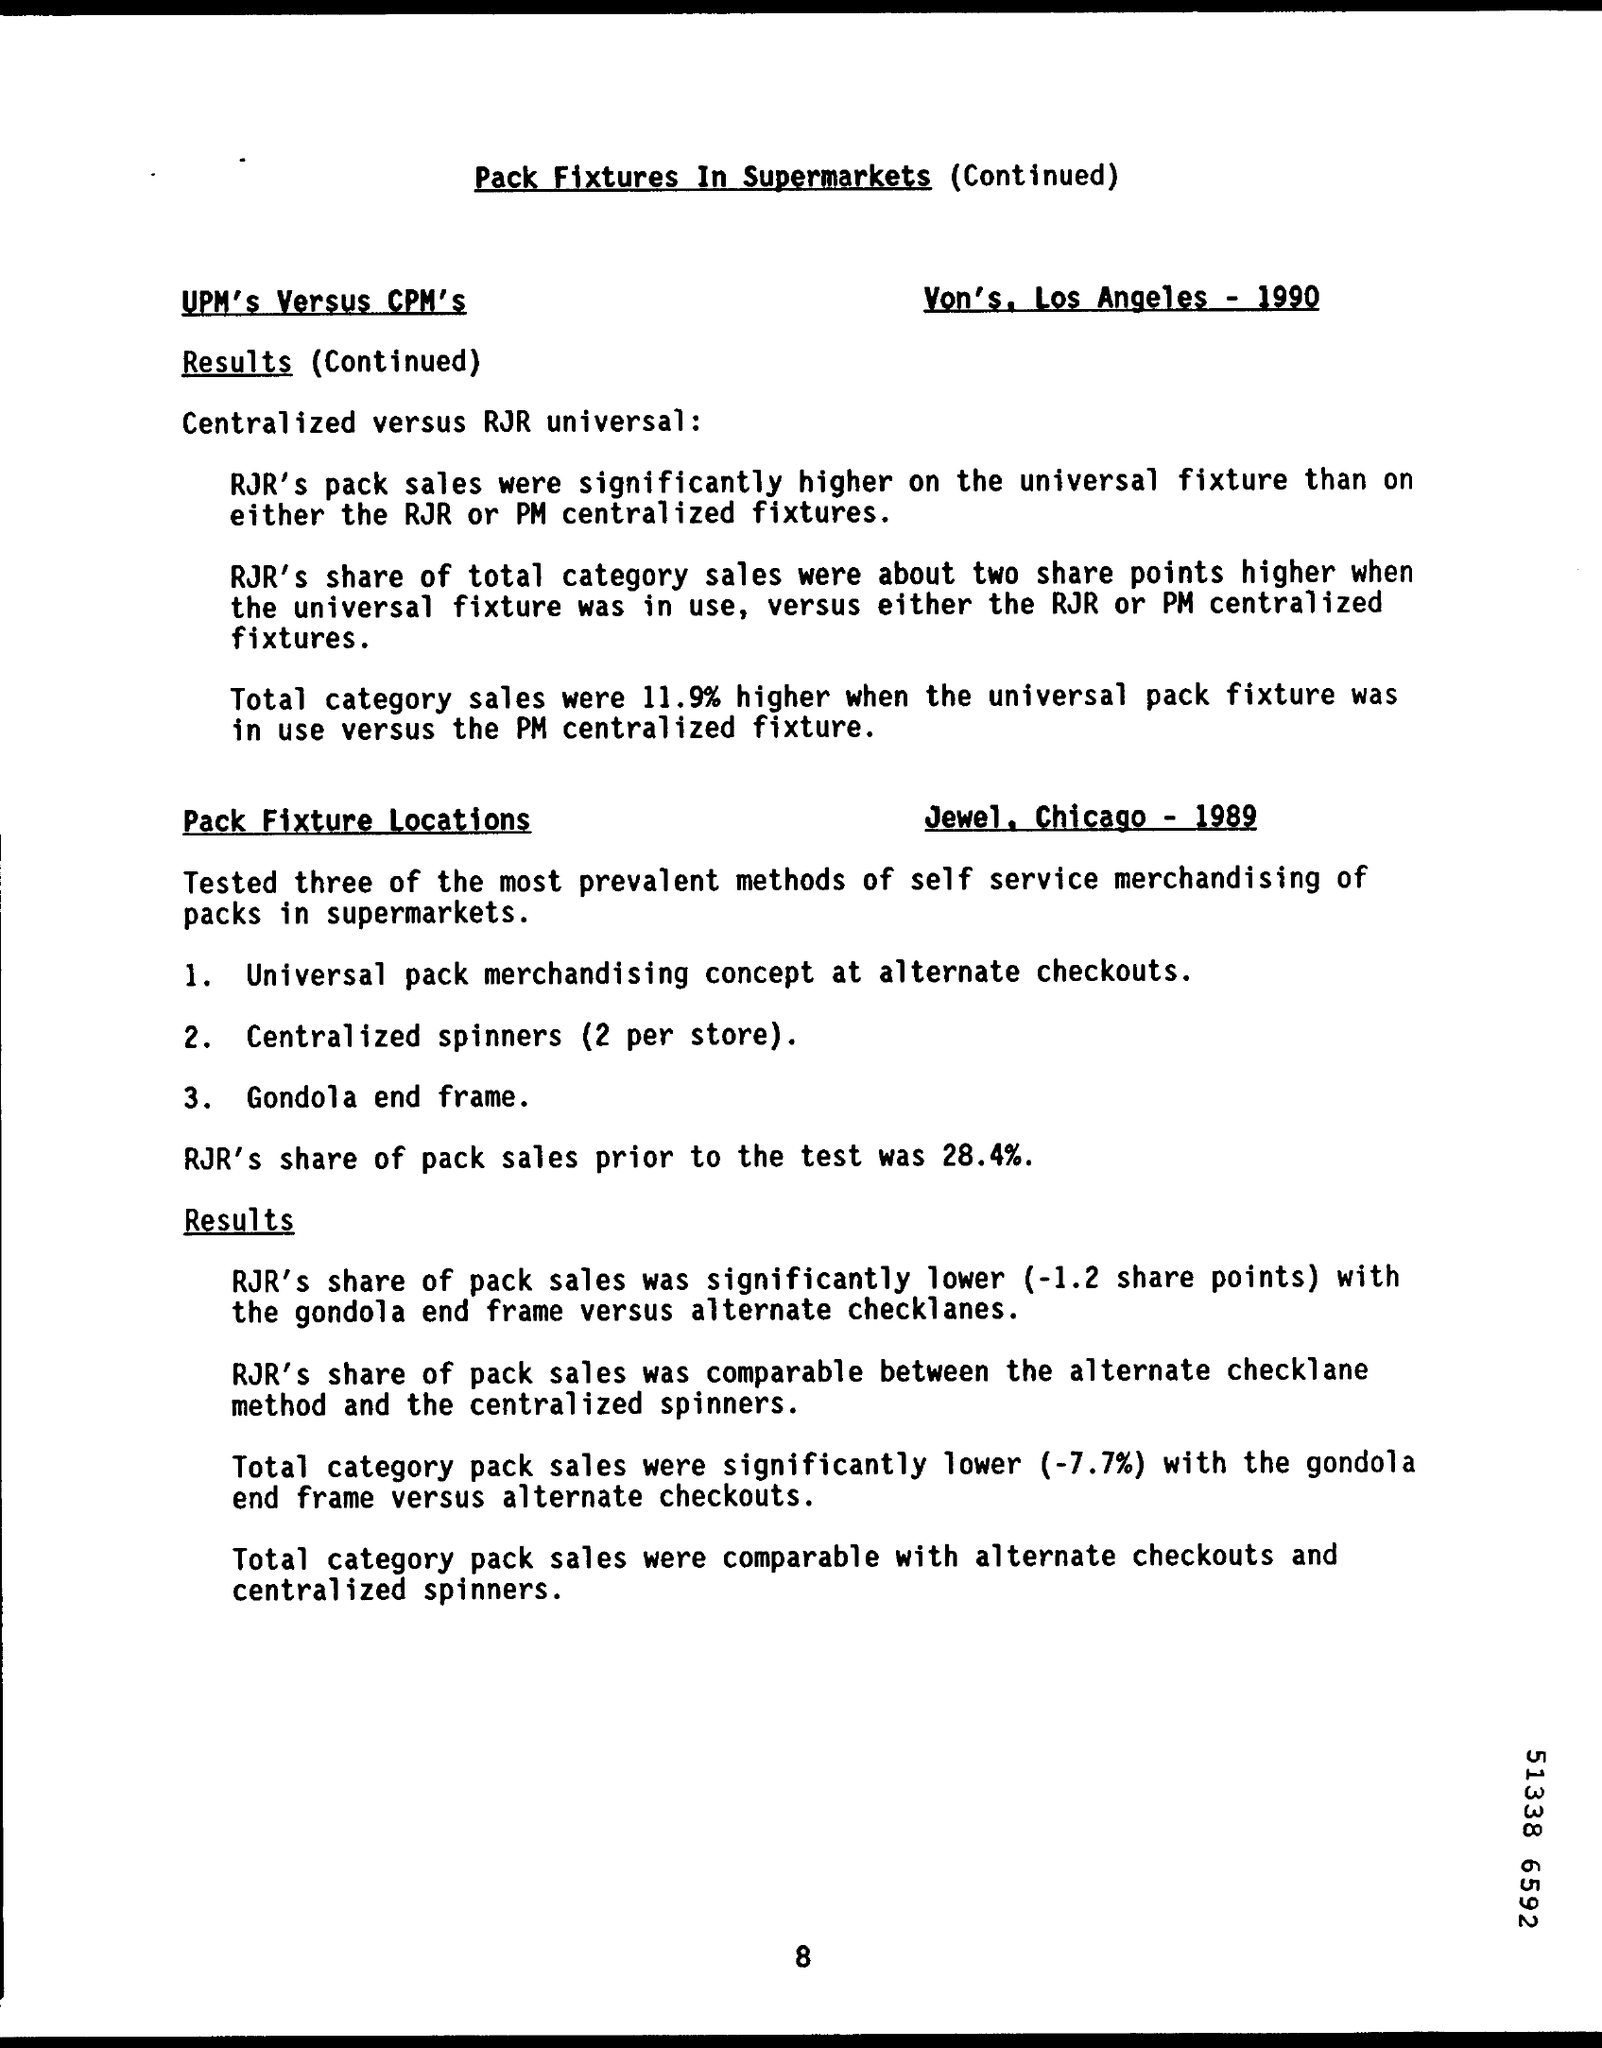What is the document title?
Offer a very short reply. Pack Fixtures in Supermarkets. What was RJR's share of pack sales prior to the test?
Provide a short and direct response. 28.4%. 